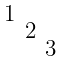<formula> <loc_0><loc_0><loc_500><loc_500>\begin{smallmatrix} & & & \\ 1 & & & \\ & 2 & & \\ & & 3 & \\ & & & \end{smallmatrix}</formula> 